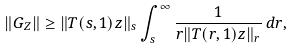Convert formula to latex. <formula><loc_0><loc_0><loc_500><loc_500>\| G _ { Z } \| \geq \| T ( s , 1 ) z \| _ { s } \int _ { s } ^ { \infty } \frac { 1 } { r \| T ( r , 1 ) z \| _ { r } } \, d r ,</formula> 